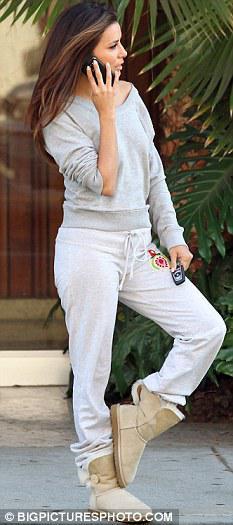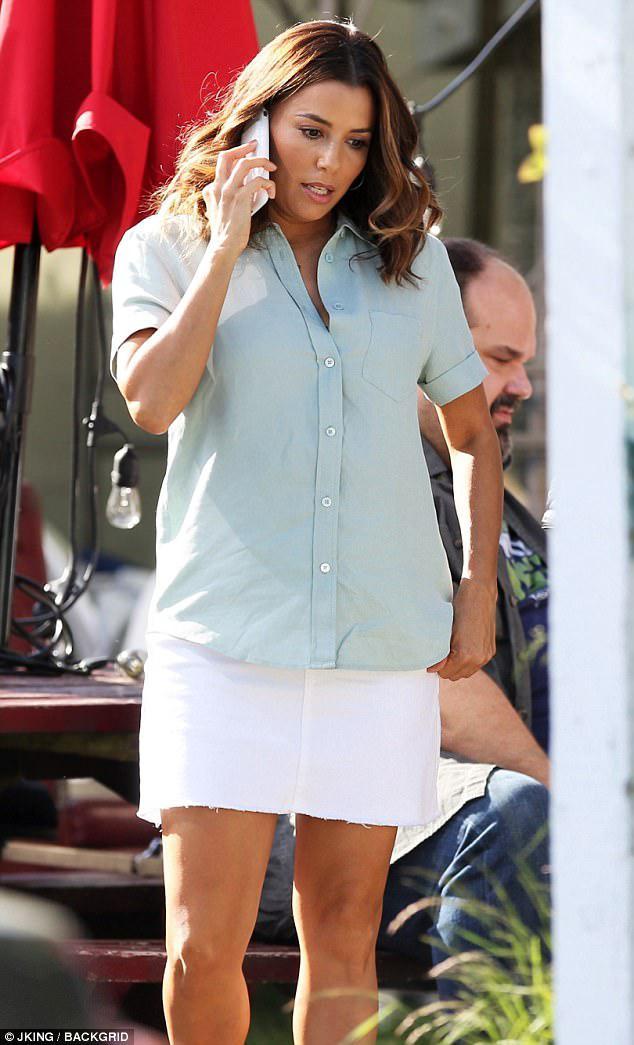The first image is the image on the left, the second image is the image on the right. For the images displayed, is the sentence "Exactly one woman is talking on her phone." factually correct? Answer yes or no. No. 